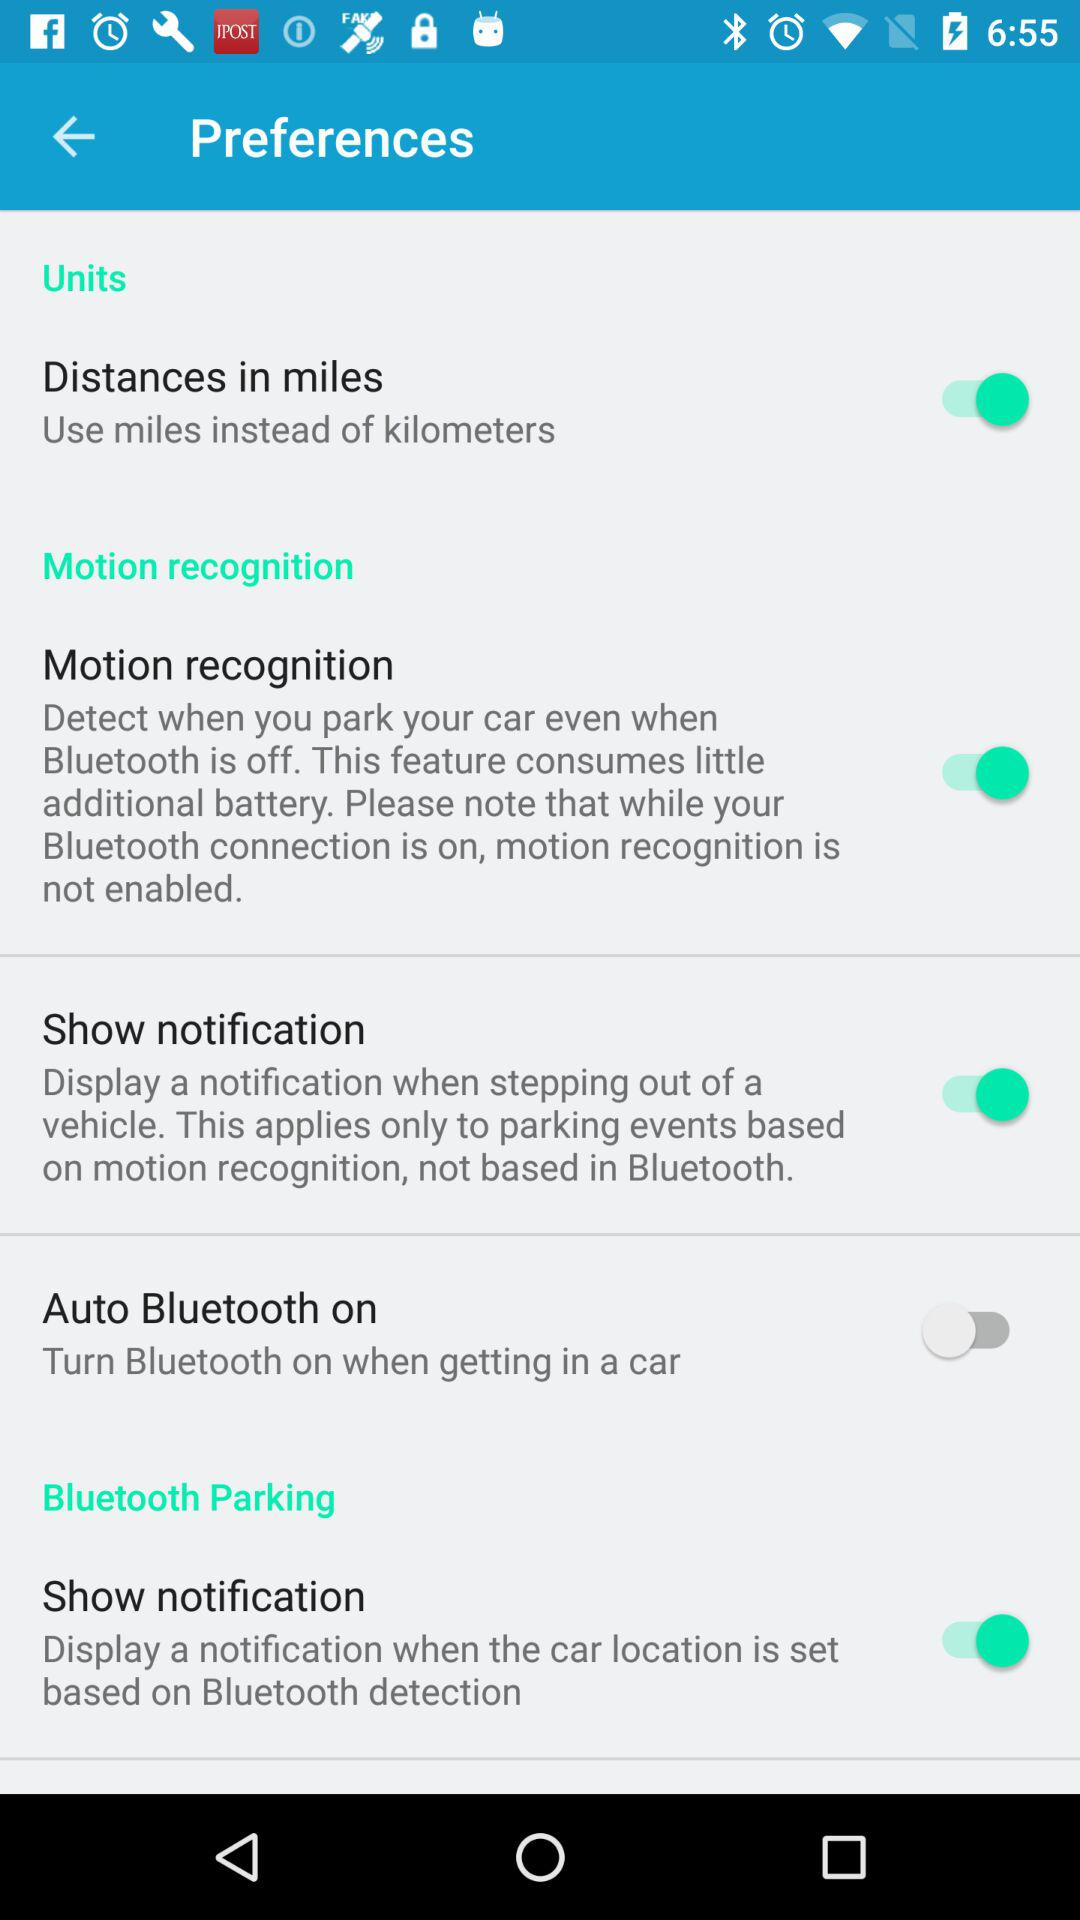Which unit of distance is shown? The shown units are miles and kilometers. 